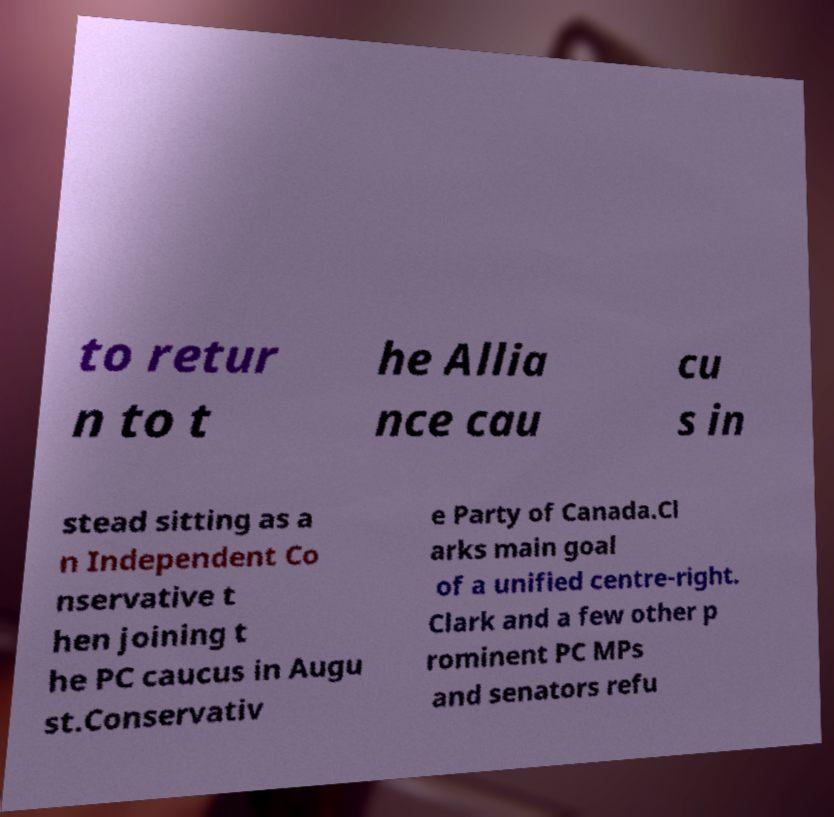Could you assist in decoding the text presented in this image and type it out clearly? to retur n to t he Allia nce cau cu s in stead sitting as a n Independent Co nservative t hen joining t he PC caucus in Augu st.Conservativ e Party of Canada.Cl arks main goal of a unified centre-right. Clark and a few other p rominent PC MPs and senators refu 